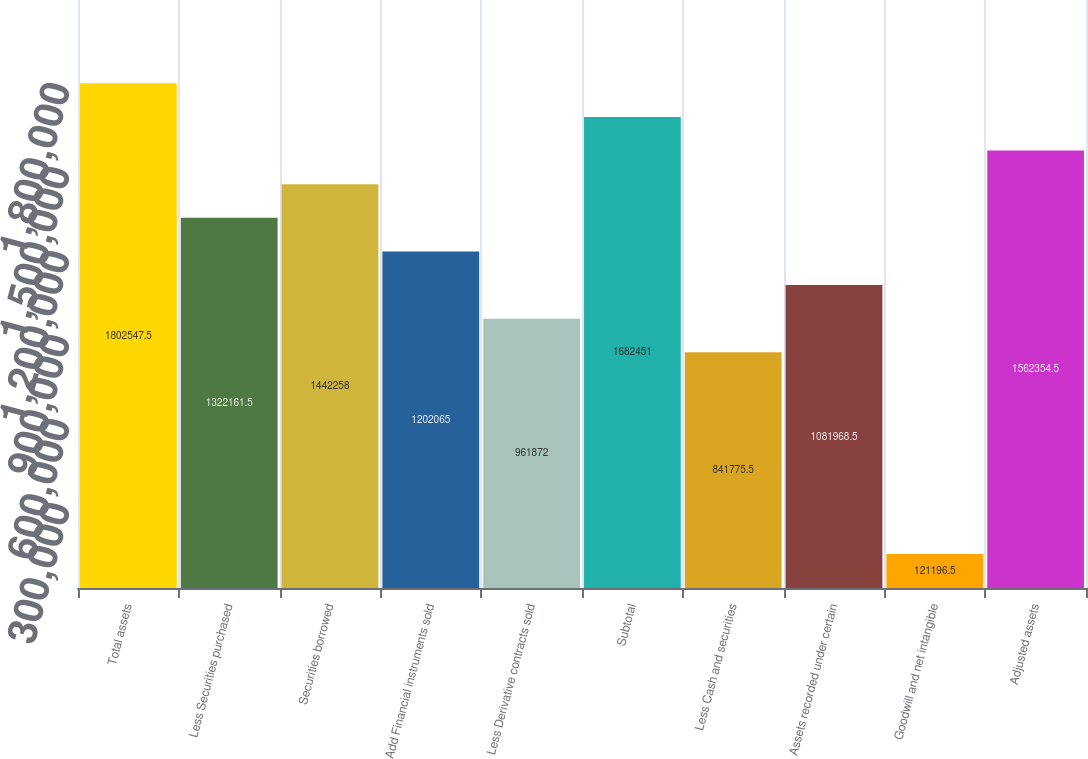Convert chart to OTSL. <chart><loc_0><loc_0><loc_500><loc_500><bar_chart><fcel>Total assets<fcel>Less Securities purchased<fcel>Securities borrowed<fcel>Add Financial instruments sold<fcel>Less Derivative contracts sold<fcel>Subtotal<fcel>Less Cash and securities<fcel>Assets recorded under certain<fcel>Goodwill and net intangible<fcel>Adjusted assets<nl><fcel>1.80255e+06<fcel>1.32216e+06<fcel>1.44226e+06<fcel>1.20206e+06<fcel>961872<fcel>1.68245e+06<fcel>841776<fcel>1.08197e+06<fcel>121196<fcel>1.56235e+06<nl></chart> 